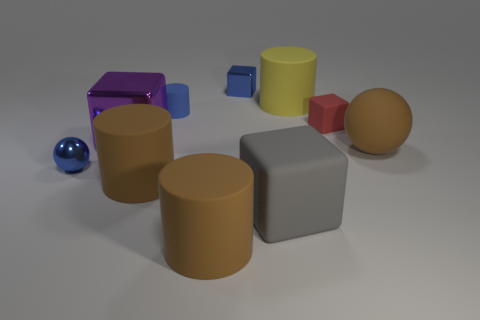Subtract all cylinders. How many objects are left? 6 Add 6 small metallic spheres. How many small metallic spheres are left? 7 Add 4 big gray matte cubes. How many big gray matte cubes exist? 5 Subtract 0 red cylinders. How many objects are left? 10 Subtract all large things. Subtract all tiny red blocks. How many objects are left? 3 